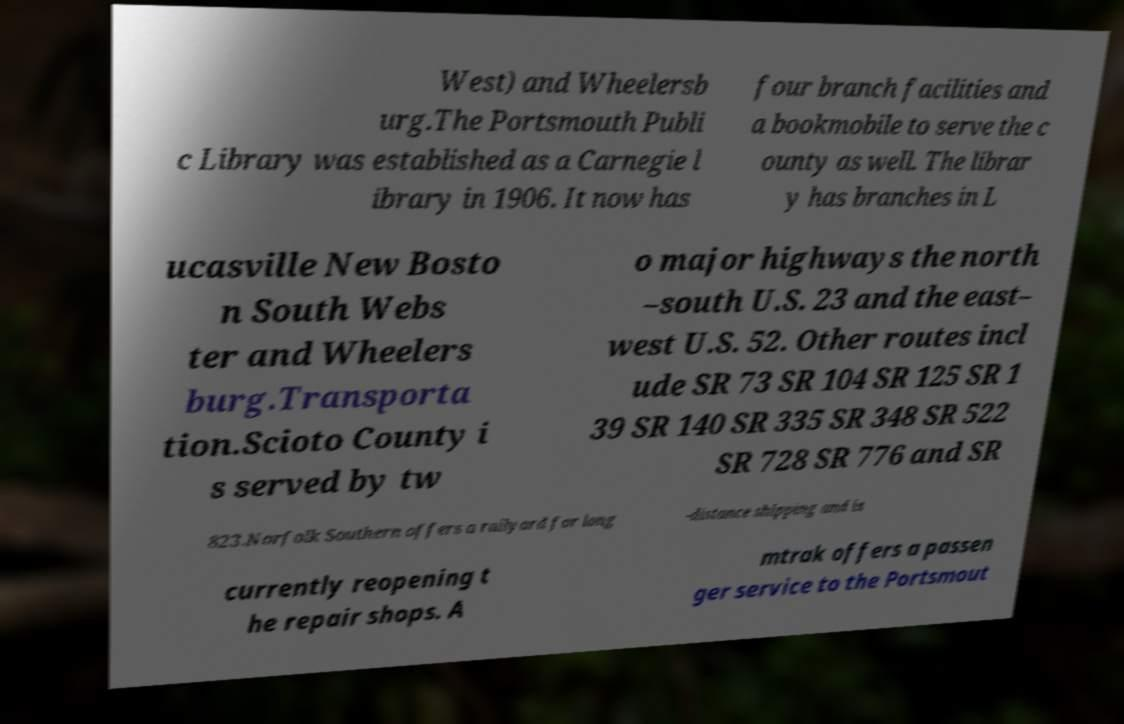Can you read and provide the text displayed in the image?This photo seems to have some interesting text. Can you extract and type it out for me? West) and Wheelersb urg.The Portsmouth Publi c Library was established as a Carnegie l ibrary in 1906. It now has four branch facilities and a bookmobile to serve the c ounty as well. The librar y has branches in L ucasville New Bosto n South Webs ter and Wheelers burg.Transporta tion.Scioto County i s served by tw o major highways the north –south U.S. 23 and the east– west U.S. 52. Other routes incl ude SR 73 SR 104 SR 125 SR 1 39 SR 140 SR 335 SR 348 SR 522 SR 728 SR 776 and SR 823.Norfolk Southern offers a railyard for long -distance shipping and is currently reopening t he repair shops. A mtrak offers a passen ger service to the Portsmout 